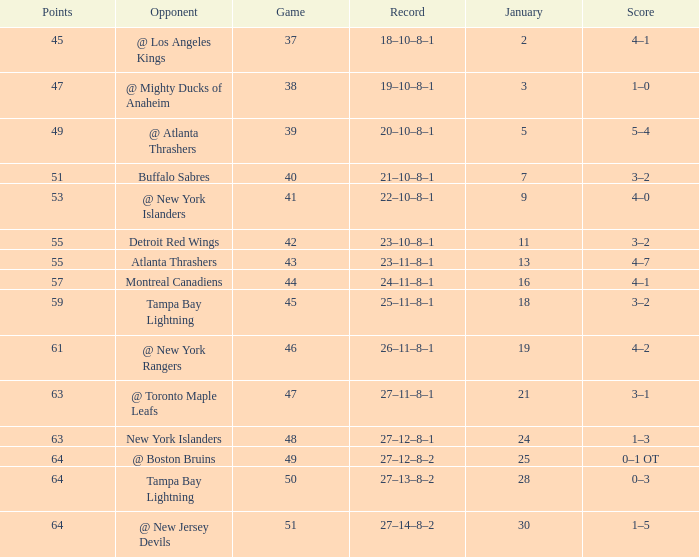Which Points have a Score of 4–1, and a Record of 18–10–8–1, and a January larger than 2? None. 